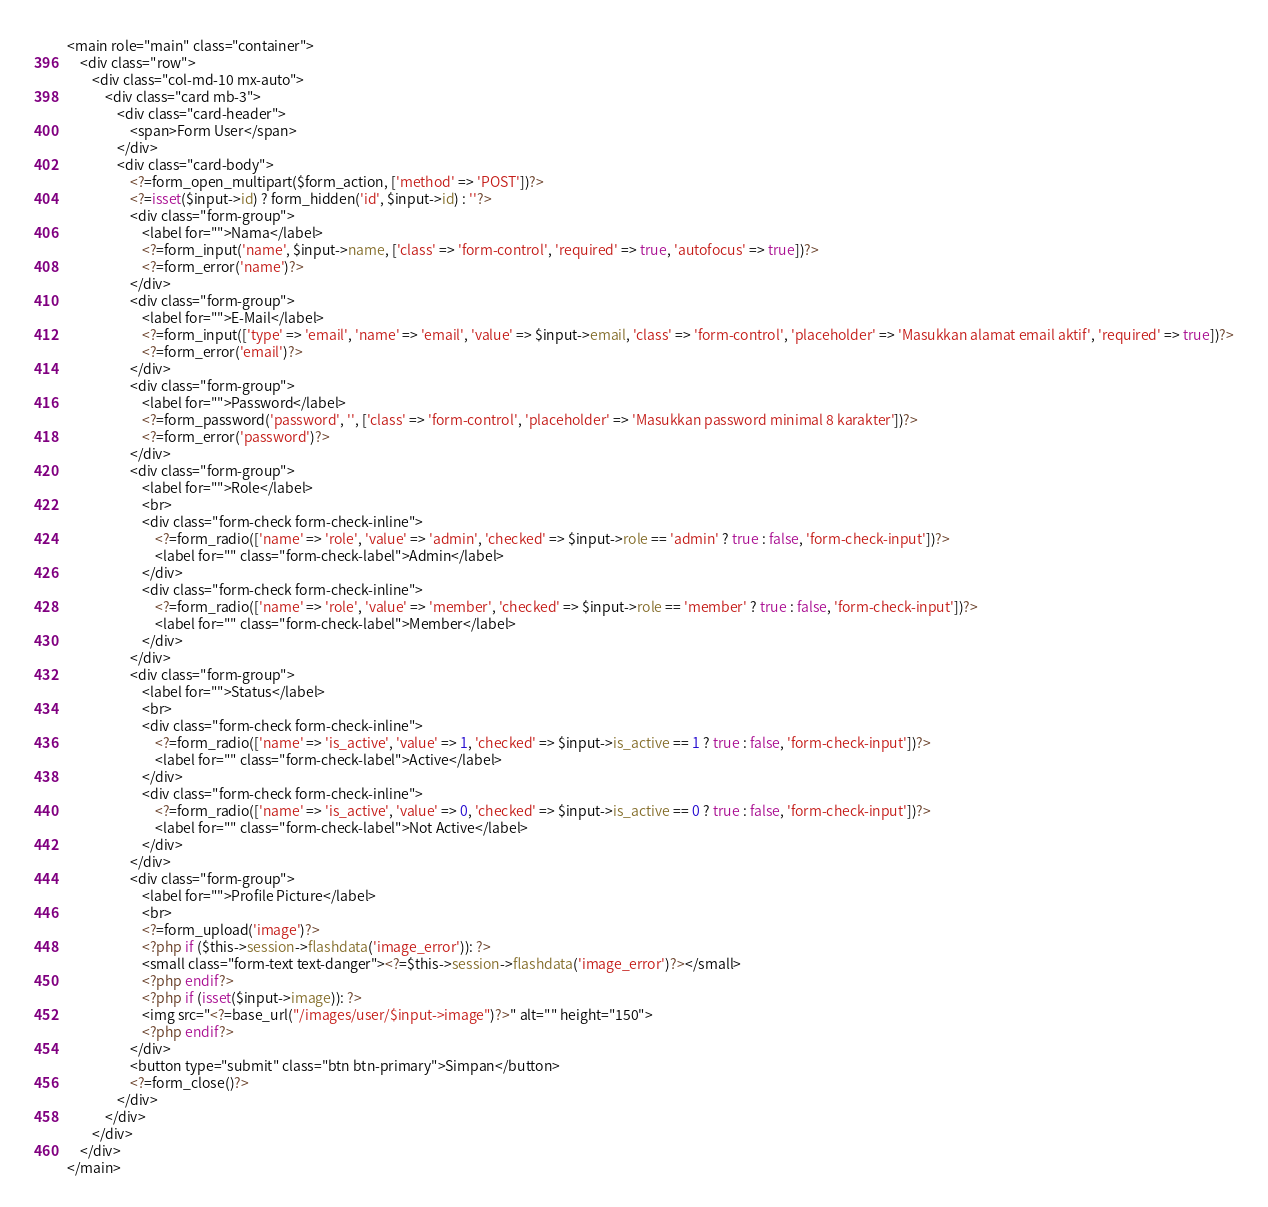<code> <loc_0><loc_0><loc_500><loc_500><_PHP_><main role="main" class="container">
    <div class="row">
        <div class="col-md-10 mx-auto">
            <div class="card mb-3">
                <div class="card-header">
                    <span>Form User</span>
                </div>
                <div class="card-body">
                    <?=form_open_multipart($form_action, ['method' => 'POST'])?>
                    <?=isset($input->id) ? form_hidden('id', $input->id) : ''?>
                    <div class="form-group">
                        <label for="">Nama</label>
                        <?=form_input('name', $input->name, ['class' => 'form-control', 'required' => true, 'autofocus' => true])?>
                        <?=form_error('name')?>
                    </div>
                    <div class="form-group">
                        <label for="">E-Mail</label>
                        <?=form_input(['type' => 'email', 'name' => 'email', 'value' => $input->email, 'class' => 'form-control', 'placeholder' => 'Masukkan alamat email aktif', 'required' => true])?>
                        <?=form_error('email')?>
                    </div>
                    <div class="form-group">
                        <label for="">Password</label>
                        <?=form_password('password', '', ['class' => 'form-control', 'placeholder' => 'Masukkan password minimal 8 karakter'])?>
                        <?=form_error('password')?>
                    </div>
                    <div class="form-group">
                        <label for="">Role</label>
                        <br>
                        <div class="form-check form-check-inline">
                            <?=form_radio(['name' => 'role', 'value' => 'admin', 'checked' => $input->role == 'admin' ? true : false, 'form-check-input'])?>
                            <label for="" class="form-check-label">Admin</label>
                        </div>
                        <div class="form-check form-check-inline">
                            <?=form_radio(['name' => 'role', 'value' => 'member', 'checked' => $input->role == 'member' ? true : false, 'form-check-input'])?>
                            <label for="" class="form-check-label">Member</label>
                        </div>
                    </div>
                    <div class="form-group">
                        <label for="">Status</label>
                        <br>
                        <div class="form-check form-check-inline">
                            <?=form_radio(['name' => 'is_active', 'value' => 1, 'checked' => $input->is_active == 1 ? true : false, 'form-check-input'])?>
                            <label for="" class="form-check-label">Active</label>
                        </div>
                        <div class="form-check form-check-inline">
                            <?=form_radio(['name' => 'is_active', 'value' => 0, 'checked' => $input->is_active == 0 ? true : false, 'form-check-input'])?>
                            <label for="" class="form-check-label">Not Active</label>
                        </div>
                    </div>
                    <div class="form-group">
                        <label for="">Profile Picture</label>
                        <br>
                        <?=form_upload('image')?>
                        <?php if ($this->session->flashdata('image_error')): ?>
                        <small class="form-text text-danger"><?=$this->session->flashdata('image_error')?></small>
                        <?php endif?>
                        <?php if (isset($input->image)): ?>
                        <img src="<?=base_url("/images/user/$input->image")?>" alt="" height="150">
                        <?php endif?>
                    </div>
                    <button type="submit" class="btn btn-primary">Simpan</button>
                    <?=form_close()?>
                </div>
            </div>
        </div>
    </div>
</main></code> 